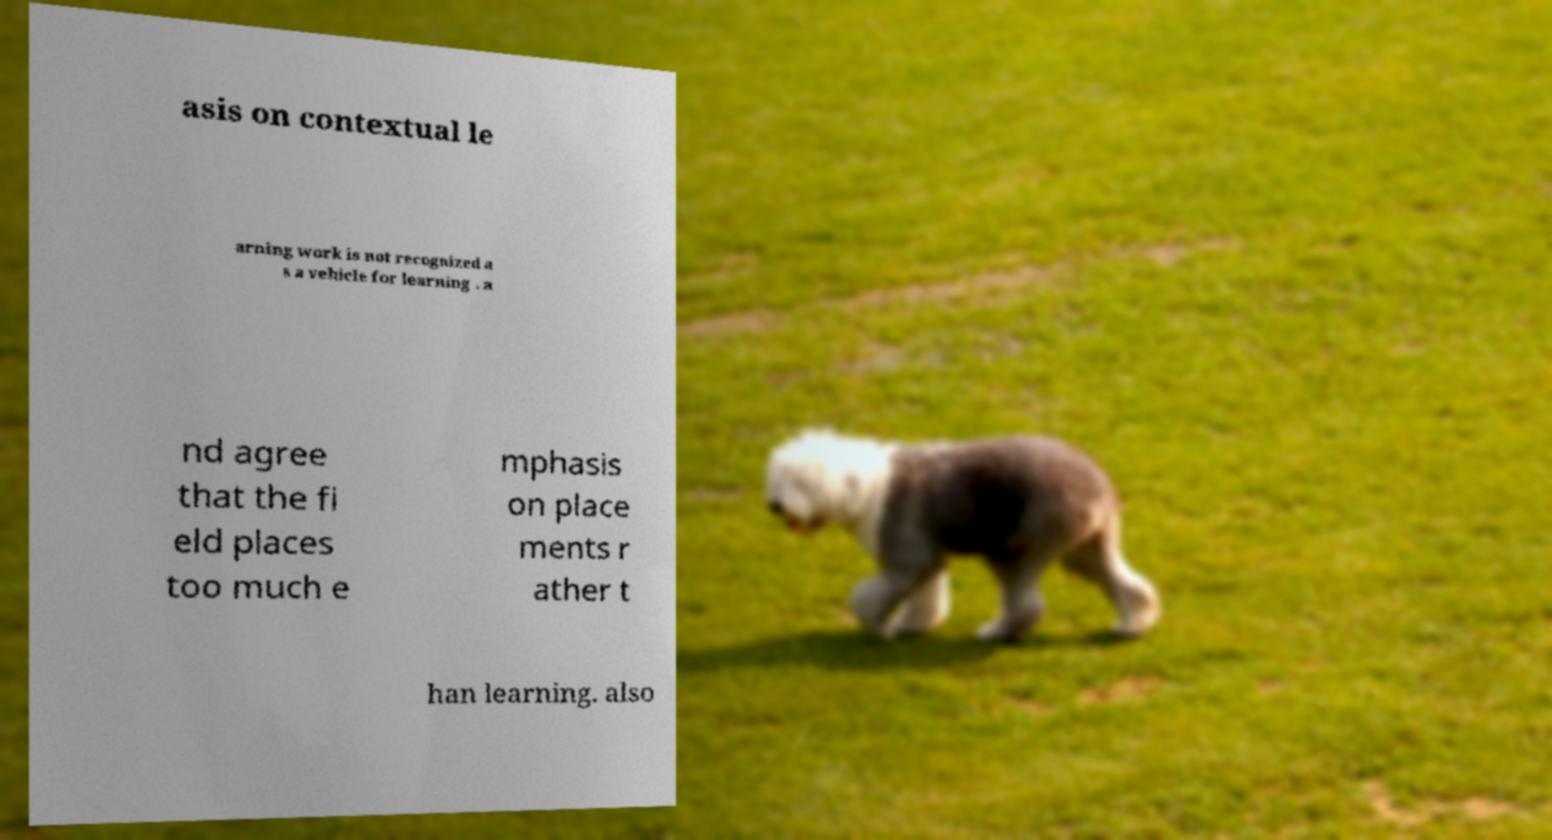What messages or text are displayed in this image? I need them in a readable, typed format. asis on contextual le arning work is not recognized a s a vehicle for learning . a nd agree that the fi eld places too much e mphasis on place ments r ather t han learning. also 